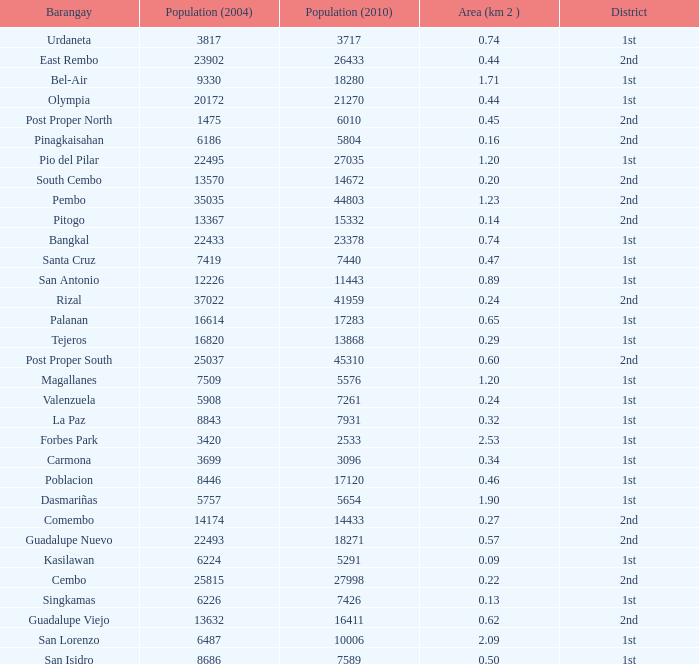What is the area where barangay is guadalupe viejo? 0.62. 